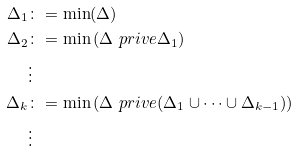Convert formula to latex. <formula><loc_0><loc_0><loc_500><loc_500>\Delta _ { 1 } & \colon = \min ( \Delta ) \\ \Delta _ { 2 } & \colon = \min \left ( \Delta \ p r i v e \Delta _ { 1 } \right ) \\ & \vdots \\ \Delta _ { k } & \colon = \min \left ( \Delta \ p r i v e ( \Delta _ { 1 } \cup \cdots \cup \Delta _ { k - 1 } ) \right ) \\ & \vdots \\</formula> 